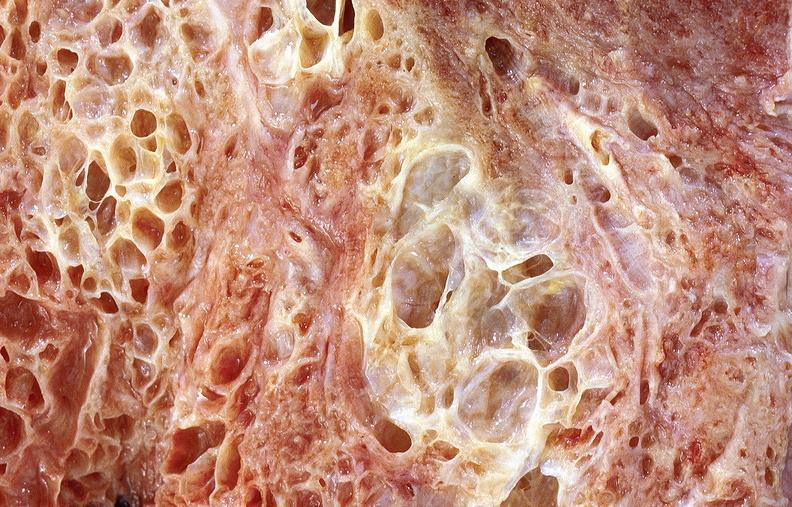what does this image show?
Answer the question using a single word or phrase. Lung fibrosis 